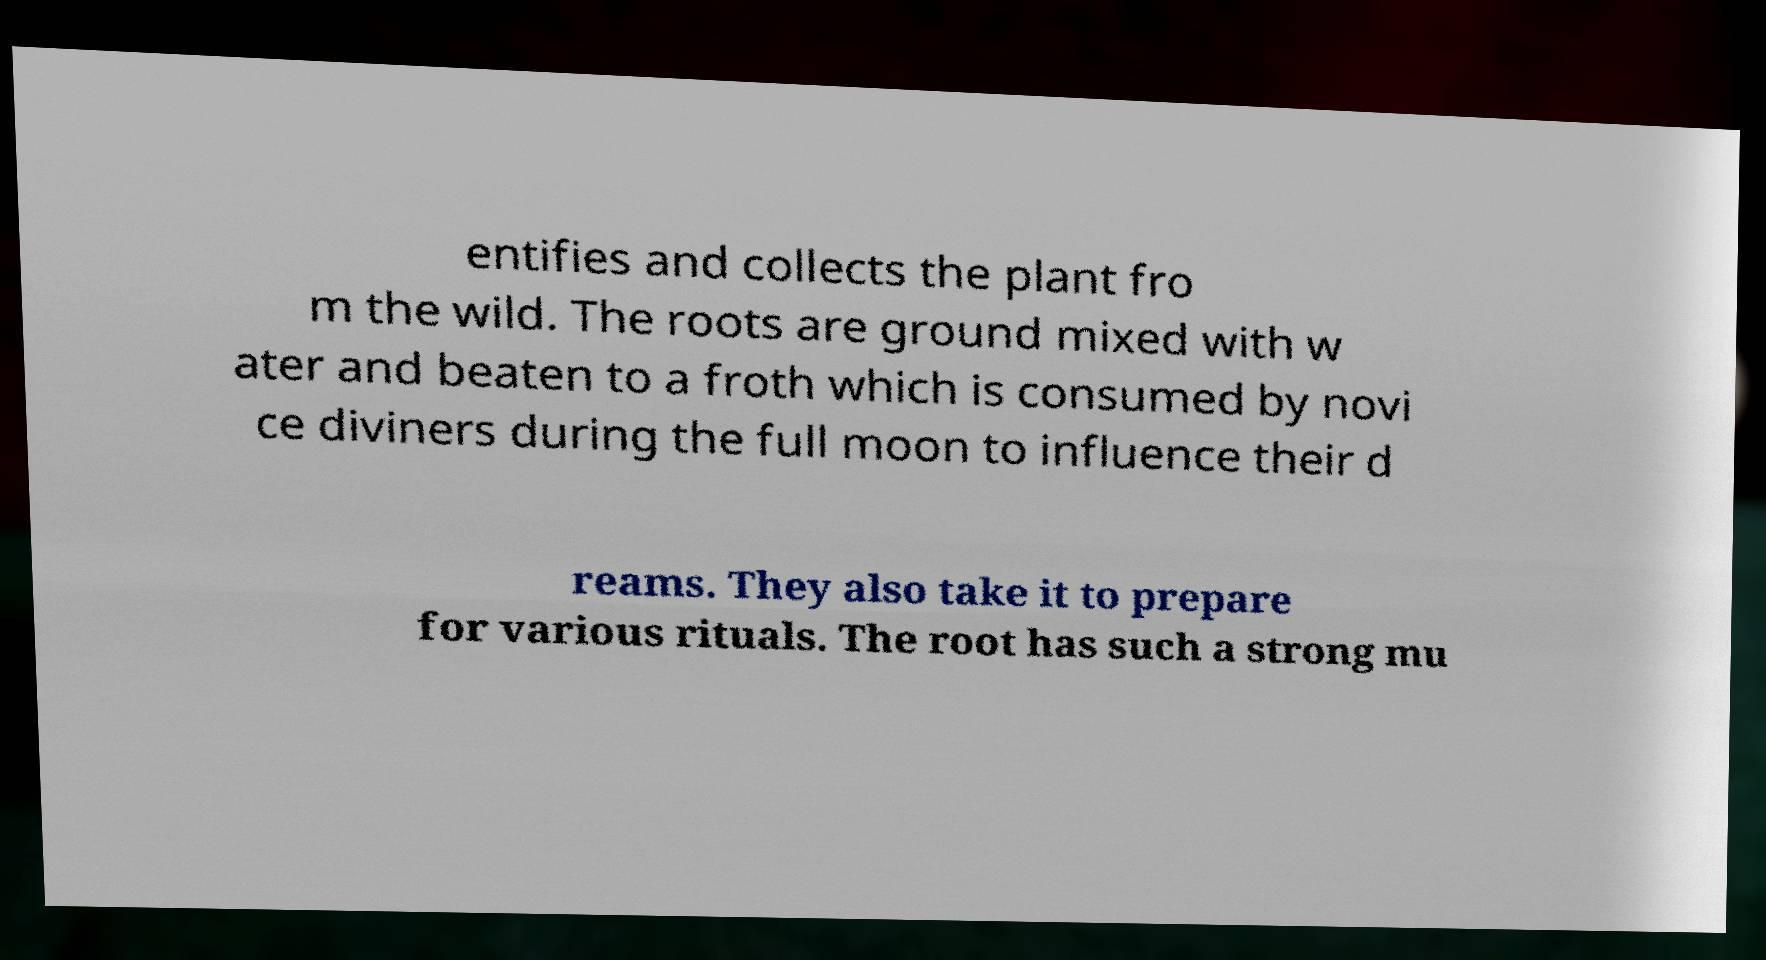Please read and relay the text visible in this image. What does it say? entifies and collects the plant fro m the wild. The roots are ground mixed with w ater and beaten to a froth which is consumed by novi ce diviners during the full moon to influence their d reams. They also take it to prepare for various rituals. The root has such a strong mu 